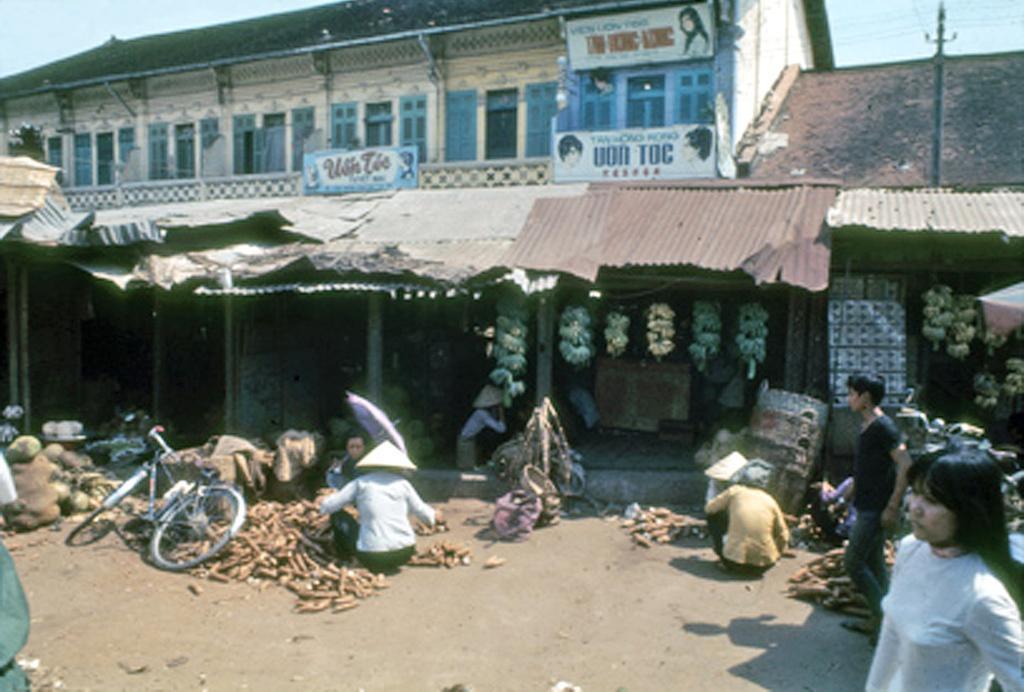Could you give a brief overview of what you see in this image? In the center of the image there are buildings and we can see bananas. At the bottom there is a bicycle and we can see people sitting on the road. On the right there are two people and there are things placed on the road. On the right there is a pole. In the background there is sky. 